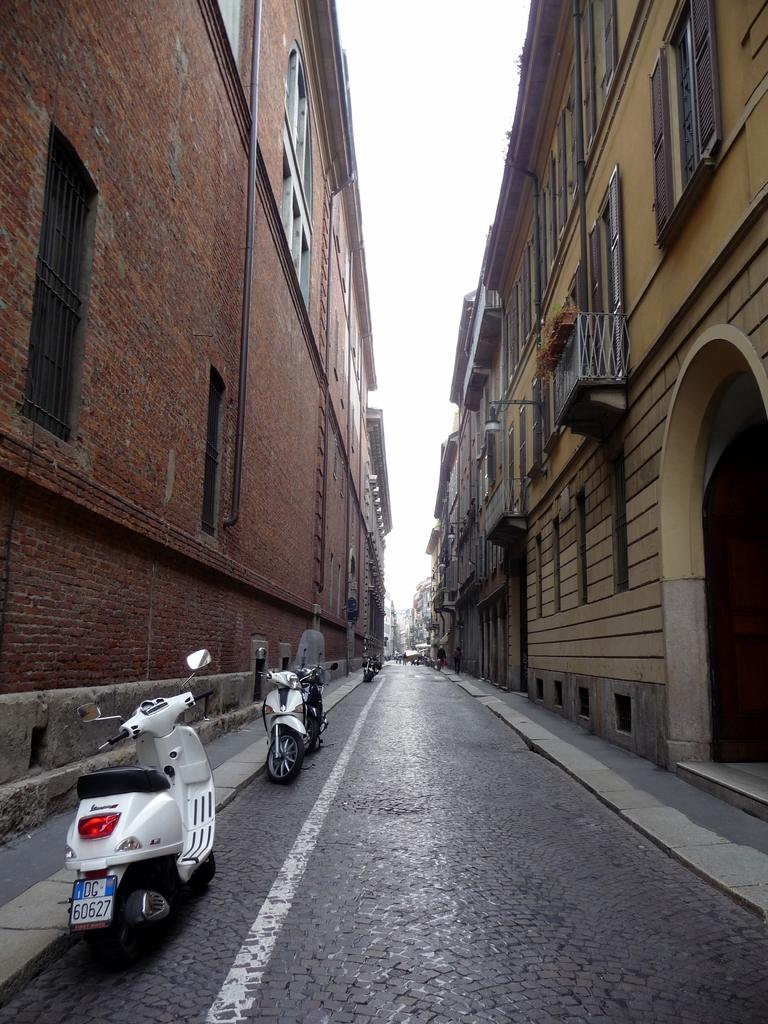What can be seen on the road in the image? There are vehicles parked on the road. What is visible on both sides of the road? There are buildings on either side of the road. What type of veil can be seen covering the buildings in the image? There is no veil present in the image; the buildings are visible without any covering. How many bones are visible on the road in the image? There are no bones visible on the road in the image. 